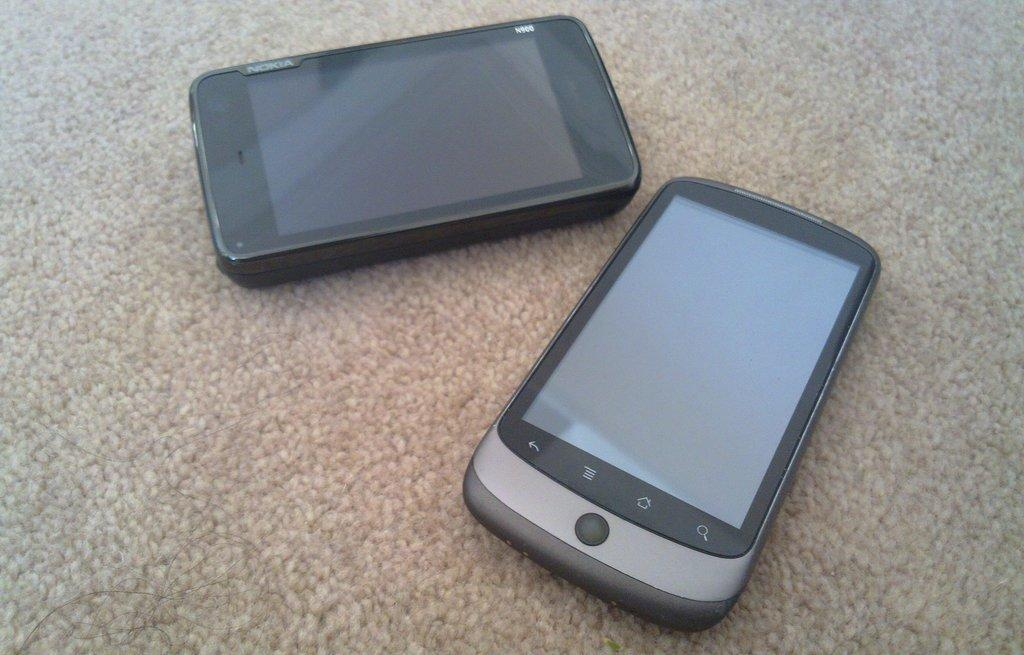How many mobiles can be seen in the image? There are two mobiles in the image. Where are the mobiles located? The mobiles are on the floor. What is present at the bottom of the image? There is a floor mat at the bottom of the image. What type of arch can be seen in the image? There is no arch present in the image. What industry is depicted in the image? The image does not depict any specific industry. 